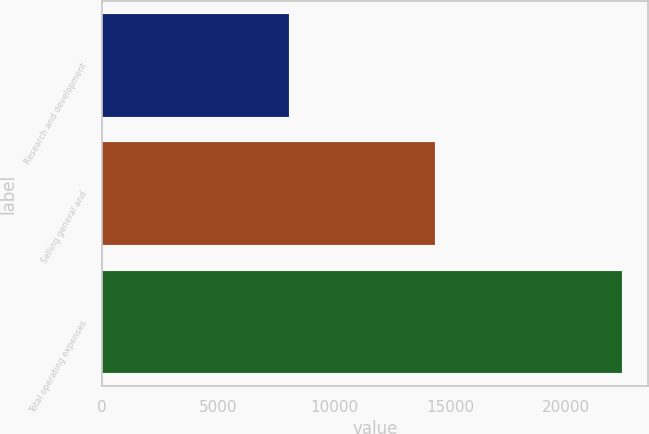Convert chart. <chart><loc_0><loc_0><loc_500><loc_500><bar_chart><fcel>Research and development<fcel>Selling general and<fcel>Total operating expenses<nl><fcel>8067<fcel>14329<fcel>22396<nl></chart> 